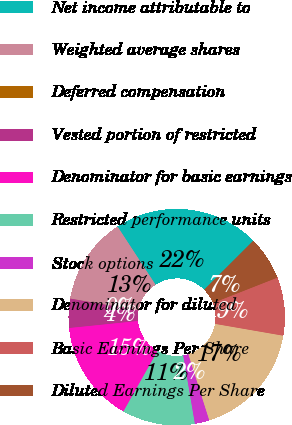Convert chart to OTSL. <chart><loc_0><loc_0><loc_500><loc_500><pie_chart><fcel>Net income attributable to<fcel>Weighted average shares<fcel>Deferred compensation<fcel>Vested portion of restricted<fcel>Denominator for basic earnings<fcel>Restricted performance units<fcel>Stock options<fcel>Denominator for diluted<fcel>Basic Earnings Per Share<fcel>Diluted Earnings Per Share<nl><fcel>21.73%<fcel>13.04%<fcel>0.01%<fcel>4.35%<fcel>15.21%<fcel>10.87%<fcel>2.18%<fcel>17.39%<fcel>8.7%<fcel>6.52%<nl></chart> 